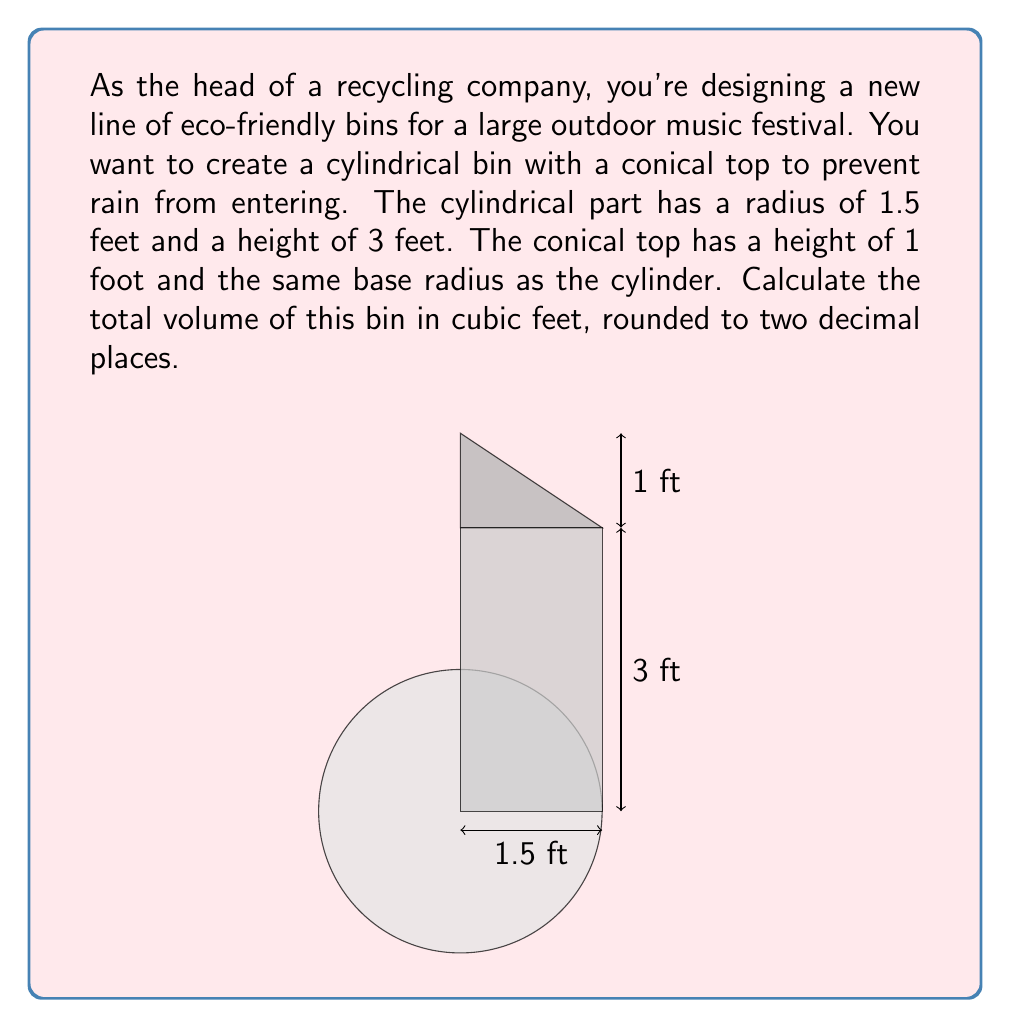Help me with this question. To solve this problem, we need to calculate the volume of the cylindrical part and the conical part separately, then add them together.

1. Volume of the cylinder:
   The formula for the volume of a cylinder is $V_c = \pi r^2 h$
   where $r$ is the radius and $h$ is the height.
   
   $V_c = \pi (1.5 \text{ ft})^2 (3 \text{ ft})$
   $V_c = \pi (2.25 \text{ ft}^2) (3 \text{ ft})$
   $V_c = 6.75\pi \text{ ft}^3$

2. Volume of the cone:
   The formula for the volume of a cone is $V_n = \frac{1}{3}\pi r^2 h$
   where $r$ is the radius of the base and $h$ is the height.
   
   $V_n = \frac{1}{3}\pi (1.5 \text{ ft})^2 (1 \text{ ft})$
   $V_n = \frac{1}{3}\pi (2.25 \text{ ft}^2) (1 \text{ ft})$
   $V_n = 0.75\pi \text{ ft}^3$

3. Total volume:
   $V_{\text{total}} = V_c + V_n$
   $V_{\text{total}} = 6.75\pi \text{ ft}^3 + 0.75\pi \text{ ft}^3$
   $V_{\text{total}} = 7.5\pi \text{ ft}^3$

4. Substituting $\pi \approx 3.14159$:
   $V_{\text{total}} \approx 7.5 \times 3.14159 \text{ ft}^3$
   $V_{\text{total}} \approx 23.56 \text{ ft}^3$

Therefore, the total volume of the bin, rounded to two decimal places, is 23.56 cubic feet.
Answer: $23.56 \text{ ft}^3$ 